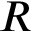<formula> <loc_0><loc_0><loc_500><loc_500>R</formula> 